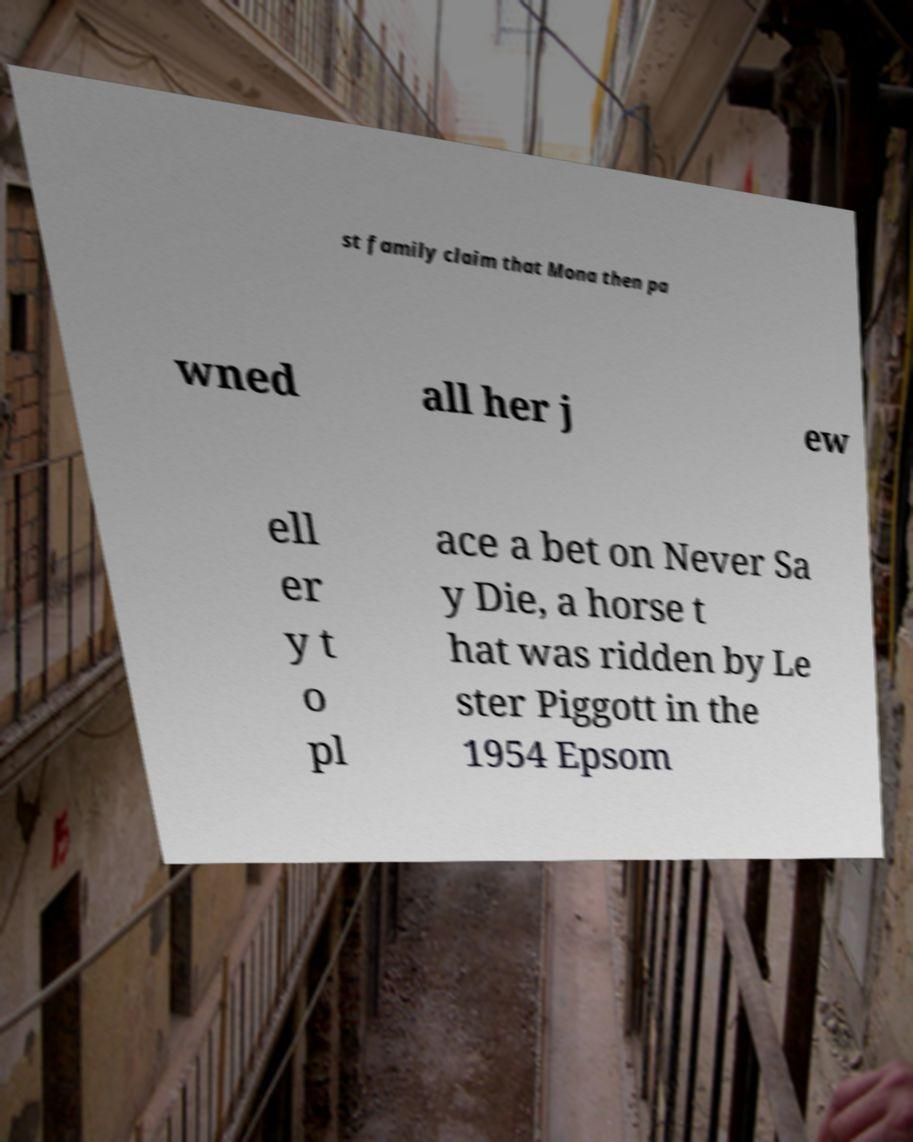What messages or text are displayed in this image? I need them in a readable, typed format. st family claim that Mona then pa wned all her j ew ell er y t o pl ace a bet on Never Sa y Die, a horse t hat was ridden by Le ster Piggott in the 1954 Epsom 